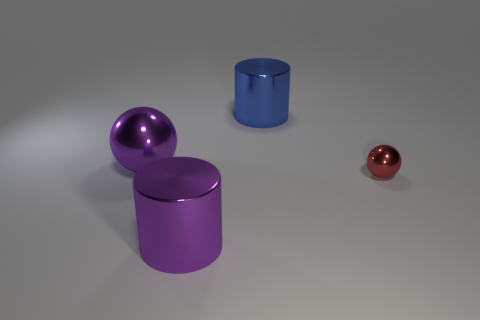Add 4 red metallic objects. How many objects exist? 8 Add 2 blue metal cylinders. How many blue metal cylinders are left? 3 Add 1 blue cylinders. How many blue cylinders exist? 2 Subtract 1 red spheres. How many objects are left? 3 Subtract 2 cylinders. How many cylinders are left? 0 Subtract all cyan cylinders. Subtract all yellow balls. How many cylinders are left? 2 Subtract all green balls. How many yellow cylinders are left? 0 Subtract all big blue spheres. Subtract all metallic things. How many objects are left? 0 